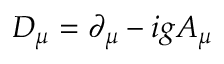<formula> <loc_0><loc_0><loc_500><loc_500>\ D _ { \mu } = \partial _ { \mu } - i g A _ { \mu }</formula> 